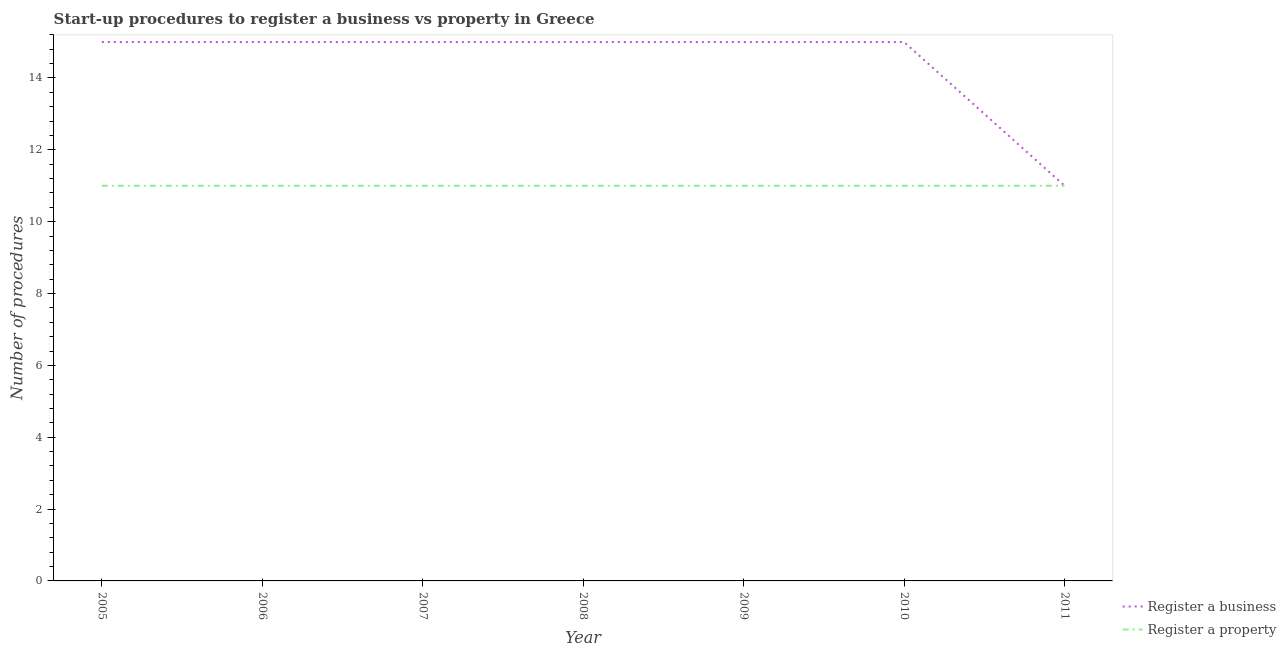How many different coloured lines are there?
Keep it short and to the point. 2. Is the number of lines equal to the number of legend labels?
Your answer should be very brief. Yes. What is the number of procedures to register a business in 2009?
Provide a succinct answer. 15. Across all years, what is the maximum number of procedures to register a business?
Give a very brief answer. 15. Across all years, what is the minimum number of procedures to register a property?
Give a very brief answer. 11. What is the total number of procedures to register a business in the graph?
Offer a very short reply. 101. What is the average number of procedures to register a business per year?
Keep it short and to the point. 14.43. In the year 2006, what is the difference between the number of procedures to register a business and number of procedures to register a property?
Your answer should be compact. 4. What is the ratio of the number of procedures to register a business in 2008 to that in 2009?
Offer a terse response. 1. Is the number of procedures to register a property in 2006 less than that in 2011?
Keep it short and to the point. No. Is the difference between the number of procedures to register a property in 2005 and 2008 greater than the difference between the number of procedures to register a business in 2005 and 2008?
Provide a short and direct response. No. What is the difference between the highest and the lowest number of procedures to register a property?
Ensure brevity in your answer.  0. Is the number of procedures to register a business strictly greater than the number of procedures to register a property over the years?
Provide a succinct answer. No. Is the number of procedures to register a business strictly less than the number of procedures to register a property over the years?
Make the answer very short. No. Are the values on the major ticks of Y-axis written in scientific E-notation?
Your answer should be compact. No. Does the graph contain any zero values?
Your answer should be very brief. No. Where does the legend appear in the graph?
Your answer should be compact. Bottom right. How are the legend labels stacked?
Your response must be concise. Vertical. What is the title of the graph?
Your answer should be compact. Start-up procedures to register a business vs property in Greece. Does "Commercial service exports" appear as one of the legend labels in the graph?
Give a very brief answer. No. What is the label or title of the X-axis?
Your answer should be compact. Year. What is the label or title of the Y-axis?
Offer a very short reply. Number of procedures. What is the Number of procedures of Register a property in 2005?
Offer a terse response. 11. What is the Number of procedures in Register a business in 2009?
Make the answer very short. 15. What is the Number of procedures of Register a property in 2011?
Your answer should be very brief. 11. Across all years, what is the minimum Number of procedures of Register a property?
Ensure brevity in your answer.  11. What is the total Number of procedures in Register a business in the graph?
Offer a terse response. 101. What is the difference between the Number of procedures in Register a business in 2005 and that in 2006?
Offer a terse response. 0. What is the difference between the Number of procedures in Register a property in 2005 and that in 2006?
Your answer should be compact. 0. What is the difference between the Number of procedures of Register a business in 2005 and that in 2007?
Your answer should be compact. 0. What is the difference between the Number of procedures of Register a business in 2005 and that in 2008?
Your response must be concise. 0. What is the difference between the Number of procedures in Register a property in 2005 and that in 2008?
Your response must be concise. 0. What is the difference between the Number of procedures of Register a property in 2005 and that in 2009?
Your answer should be very brief. 0. What is the difference between the Number of procedures in Register a property in 2005 and that in 2010?
Your answer should be very brief. 0. What is the difference between the Number of procedures in Register a property in 2005 and that in 2011?
Offer a terse response. 0. What is the difference between the Number of procedures of Register a business in 2006 and that in 2007?
Give a very brief answer. 0. What is the difference between the Number of procedures of Register a property in 2006 and that in 2008?
Keep it short and to the point. 0. What is the difference between the Number of procedures of Register a business in 2006 and that in 2009?
Your response must be concise. 0. What is the difference between the Number of procedures in Register a property in 2006 and that in 2009?
Offer a very short reply. 0. What is the difference between the Number of procedures of Register a business in 2006 and that in 2010?
Your response must be concise. 0. What is the difference between the Number of procedures in Register a property in 2006 and that in 2010?
Your answer should be very brief. 0. What is the difference between the Number of procedures of Register a business in 2006 and that in 2011?
Keep it short and to the point. 4. What is the difference between the Number of procedures in Register a property in 2006 and that in 2011?
Provide a short and direct response. 0. What is the difference between the Number of procedures in Register a business in 2007 and that in 2008?
Your response must be concise. 0. What is the difference between the Number of procedures of Register a property in 2007 and that in 2009?
Your response must be concise. 0. What is the difference between the Number of procedures of Register a business in 2008 and that in 2009?
Provide a succinct answer. 0. What is the difference between the Number of procedures in Register a property in 2008 and that in 2009?
Provide a succinct answer. 0. What is the difference between the Number of procedures of Register a business in 2008 and that in 2010?
Offer a very short reply. 0. What is the difference between the Number of procedures of Register a property in 2008 and that in 2010?
Your answer should be compact. 0. What is the difference between the Number of procedures of Register a property in 2008 and that in 2011?
Your answer should be very brief. 0. What is the difference between the Number of procedures in Register a business in 2009 and that in 2010?
Offer a terse response. 0. What is the difference between the Number of procedures in Register a property in 2009 and that in 2010?
Give a very brief answer. 0. What is the difference between the Number of procedures in Register a property in 2009 and that in 2011?
Offer a very short reply. 0. What is the difference between the Number of procedures of Register a business in 2005 and the Number of procedures of Register a property in 2007?
Your response must be concise. 4. What is the difference between the Number of procedures in Register a business in 2005 and the Number of procedures in Register a property in 2008?
Provide a short and direct response. 4. What is the difference between the Number of procedures of Register a business in 2005 and the Number of procedures of Register a property in 2011?
Keep it short and to the point. 4. What is the difference between the Number of procedures of Register a business in 2006 and the Number of procedures of Register a property in 2008?
Your answer should be compact. 4. What is the difference between the Number of procedures in Register a business in 2006 and the Number of procedures in Register a property in 2011?
Make the answer very short. 4. What is the difference between the Number of procedures of Register a business in 2007 and the Number of procedures of Register a property in 2008?
Make the answer very short. 4. What is the difference between the Number of procedures in Register a business in 2007 and the Number of procedures in Register a property in 2010?
Ensure brevity in your answer.  4. What is the difference between the Number of procedures of Register a business in 2009 and the Number of procedures of Register a property in 2010?
Ensure brevity in your answer.  4. What is the average Number of procedures in Register a business per year?
Your answer should be compact. 14.43. In the year 2006, what is the difference between the Number of procedures of Register a business and Number of procedures of Register a property?
Offer a very short reply. 4. In the year 2007, what is the difference between the Number of procedures of Register a business and Number of procedures of Register a property?
Offer a terse response. 4. In the year 2010, what is the difference between the Number of procedures in Register a business and Number of procedures in Register a property?
Ensure brevity in your answer.  4. In the year 2011, what is the difference between the Number of procedures of Register a business and Number of procedures of Register a property?
Provide a short and direct response. 0. What is the ratio of the Number of procedures of Register a business in 2005 to that in 2007?
Your response must be concise. 1. What is the ratio of the Number of procedures of Register a property in 2005 to that in 2009?
Your answer should be compact. 1. What is the ratio of the Number of procedures of Register a business in 2005 to that in 2010?
Give a very brief answer. 1. What is the ratio of the Number of procedures in Register a property in 2005 to that in 2010?
Offer a terse response. 1. What is the ratio of the Number of procedures of Register a business in 2005 to that in 2011?
Give a very brief answer. 1.36. What is the ratio of the Number of procedures in Register a property in 2005 to that in 2011?
Your answer should be very brief. 1. What is the ratio of the Number of procedures in Register a business in 2006 to that in 2008?
Ensure brevity in your answer.  1. What is the ratio of the Number of procedures in Register a property in 2006 to that in 2008?
Your response must be concise. 1. What is the ratio of the Number of procedures in Register a business in 2006 to that in 2011?
Provide a short and direct response. 1.36. What is the ratio of the Number of procedures in Register a business in 2007 to that in 2008?
Ensure brevity in your answer.  1. What is the ratio of the Number of procedures of Register a property in 2007 to that in 2008?
Offer a terse response. 1. What is the ratio of the Number of procedures of Register a business in 2007 to that in 2009?
Provide a succinct answer. 1. What is the ratio of the Number of procedures in Register a business in 2007 to that in 2010?
Give a very brief answer. 1. What is the ratio of the Number of procedures of Register a property in 2007 to that in 2010?
Your response must be concise. 1. What is the ratio of the Number of procedures in Register a business in 2007 to that in 2011?
Give a very brief answer. 1.36. What is the ratio of the Number of procedures of Register a property in 2008 to that in 2009?
Your response must be concise. 1. What is the ratio of the Number of procedures of Register a property in 2008 to that in 2010?
Your response must be concise. 1. What is the ratio of the Number of procedures of Register a business in 2008 to that in 2011?
Give a very brief answer. 1.36. What is the ratio of the Number of procedures in Register a property in 2008 to that in 2011?
Offer a very short reply. 1. What is the ratio of the Number of procedures in Register a property in 2009 to that in 2010?
Provide a succinct answer. 1. What is the ratio of the Number of procedures of Register a business in 2009 to that in 2011?
Provide a short and direct response. 1.36. What is the ratio of the Number of procedures in Register a property in 2009 to that in 2011?
Give a very brief answer. 1. What is the ratio of the Number of procedures of Register a business in 2010 to that in 2011?
Your answer should be very brief. 1.36. What is the ratio of the Number of procedures in Register a property in 2010 to that in 2011?
Offer a terse response. 1. What is the difference between the highest and the second highest Number of procedures in Register a business?
Your answer should be compact. 0. What is the difference between the highest and the lowest Number of procedures of Register a property?
Ensure brevity in your answer.  0. 